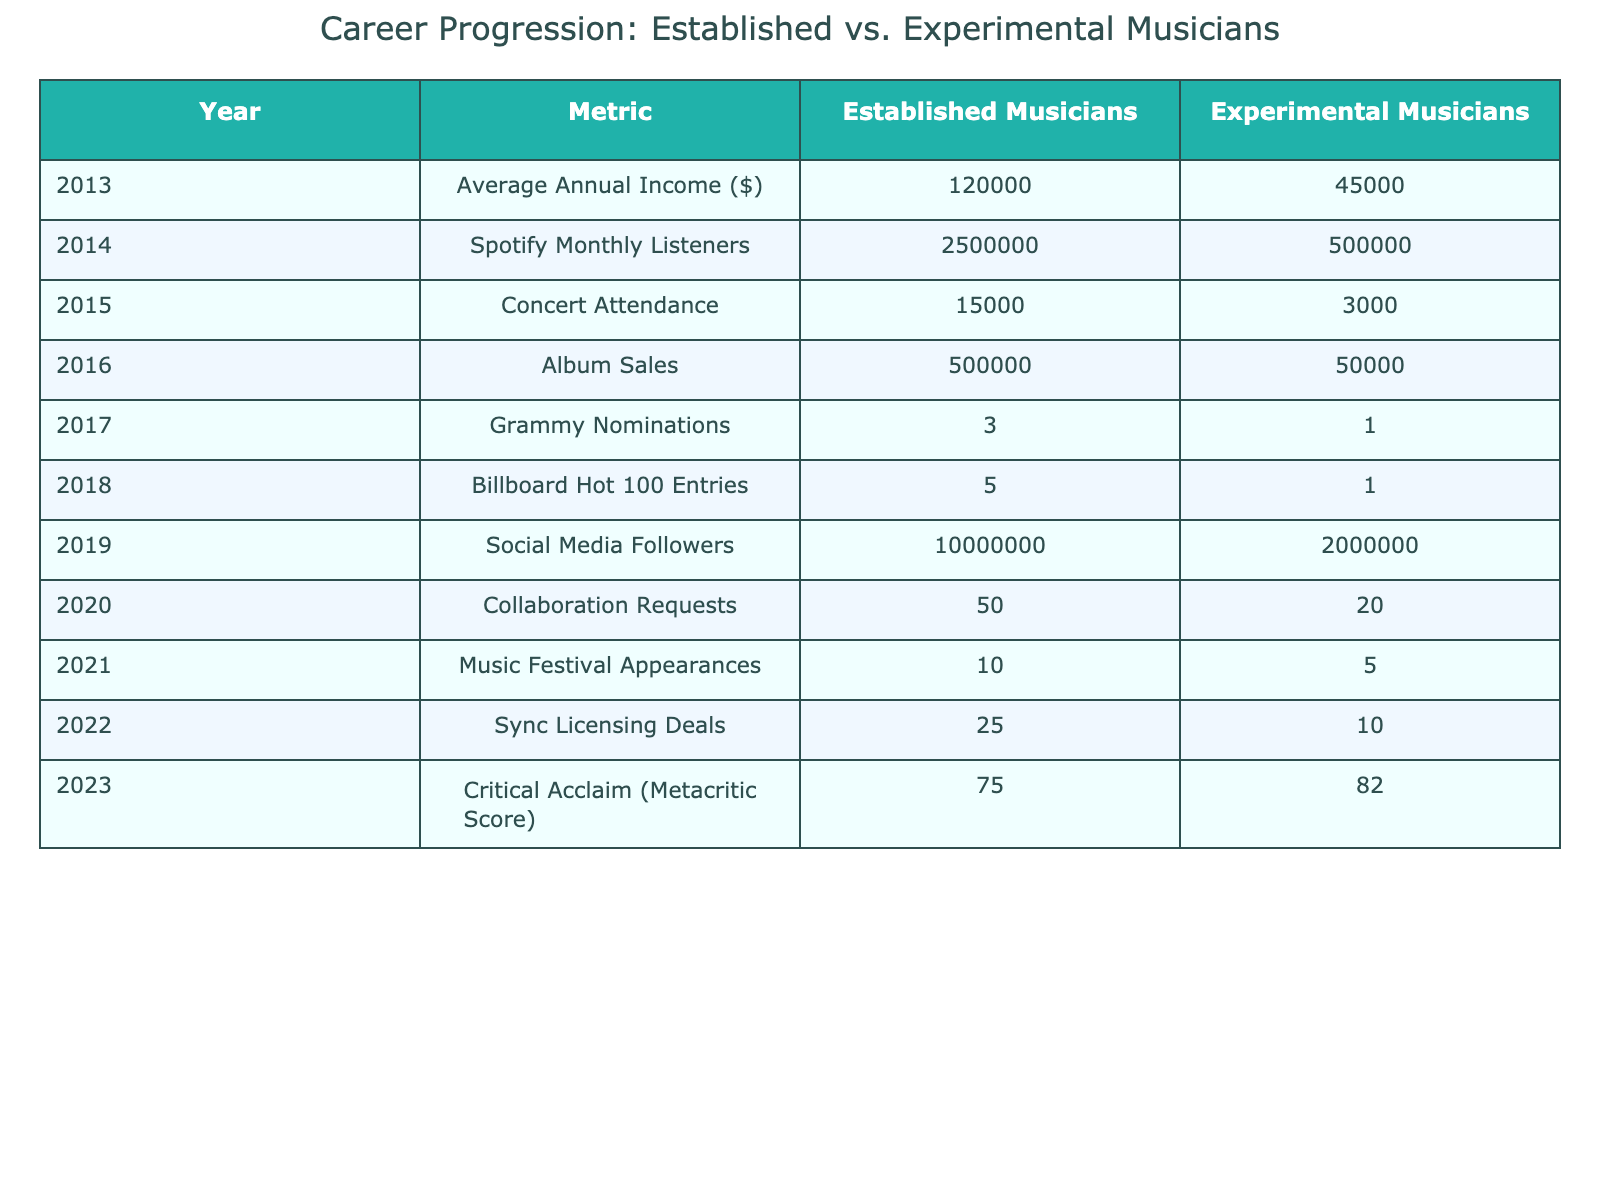What was the average annual income of established musicians in 2013? According to the table, the average annual income of established musicians in 2013 is listed as $120,000.
Answer: 120,000 How many Spotify monthly listeners did experimental musicians have in 2014? The table shows that experimental musicians had 500,000 Spotify monthly listeners in 2014.
Answer: 500,000 What was the concert attendance for established musicians in 2015? The table indicates that concert attendance for established musicians in 2015 was 15,000.
Answer: 15,000 What is the difference in album sales between established and experimental musicians in 2016? In 2016, established musicians had 500,000 album sales and experimental musicians had 50,000. The difference is 500,000 - 50,000 = 450,000.
Answer: 450,000 How many Grammy nominations did established musicians receive in 2017? The table states that established musicians received 3 Grammy nominations in 2017.
Answer: 3 Did experimental musicians have more or less Billboard Hot 100 entries than established musicians in 2018? The table shows that established musicians had 5 entries, while experimental musicians had only 1 entry in 2018, indicating that they had less.
Answer: Less How many more social media followers did established musicians have compared to experimental musicians in 2019? Established musicians had 10,000,000 followers, while experimental musicians had 2,000,000. The difference is 10,000,000 - 2,000,000 = 8,000,000.
Answer: 8,000,000 What is the average number of collaboration requests received by both groups in 2020? Established musicians received 50 collaboration requests, and experimental musicians received 20. The average is (50 + 20)/2 = 35.
Answer: 35 Which group had more appearances at music festivals in 2021, and by how many? Established musicians had 10 appearances, while experimental musicians had 5. The difference is 10 - 5 = 5, so established musicians had more by 5.
Answer: 5 What was the total number of sync licensing deals for both groups in 2022? Established musicians had 25 sync licensing deals, and experimental musicians had 10. The total is 25 + 10 = 35.
Answer: 35 How did the critical acclaim (Metacritic Score) of experimental musicians compare to established musicians in 2023? In 2023, established musicians had a Metacritic Score of 75 while experimental musicians had 82, indicating that experimental musicians had a higher score.
Answer: Experimental musicians had a higher score 